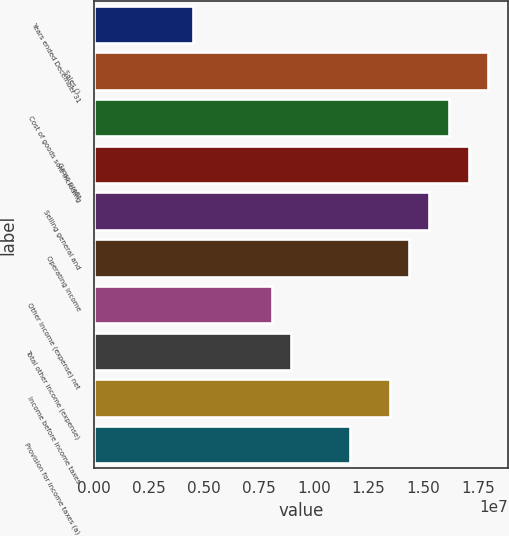Convert chart. <chart><loc_0><loc_0><loc_500><loc_500><bar_chart><fcel>Years ended December 31<fcel>Sales ()<fcel>Cost of goods sold including<fcel>Gross profit<fcel>Selling general and<fcel>Operating income<fcel>Other income (expense) net<fcel>Total other income (expense)<fcel>Income before income taxes<fcel>Provision for income taxes (a)<nl><fcel>4.48886e+06<fcel>1.79555e+07<fcel>1.61599e+07<fcel>1.70577e+07<fcel>1.52621e+07<fcel>1.43644e+07<fcel>8.07995e+06<fcel>8.97773e+06<fcel>1.34666e+07<fcel>1.1671e+07<nl></chart> 